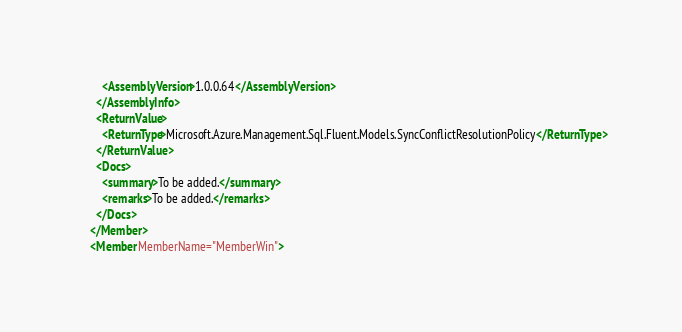<code> <loc_0><loc_0><loc_500><loc_500><_XML_>        <AssemblyVersion>1.0.0.64</AssemblyVersion>
      </AssemblyInfo>
      <ReturnValue>
        <ReturnType>Microsoft.Azure.Management.Sql.Fluent.Models.SyncConflictResolutionPolicy</ReturnType>
      </ReturnValue>
      <Docs>
        <summary>To be added.</summary>
        <remarks>To be added.</remarks>
      </Docs>
    </Member>
    <Member MemberName="MemberWin"></code> 